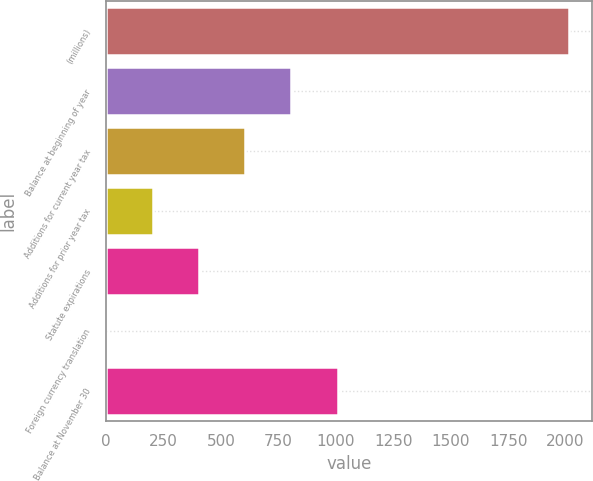Convert chart to OTSL. <chart><loc_0><loc_0><loc_500><loc_500><bar_chart><fcel>(millions)<fcel>Balance at beginning of year<fcel>Additions for current year tax<fcel>Additions for prior year tax<fcel>Statute expirations<fcel>Foreign currency translation<fcel>Balance at November 30<nl><fcel>2016<fcel>806.94<fcel>605.43<fcel>202.41<fcel>403.92<fcel>0.9<fcel>1008.45<nl></chart> 